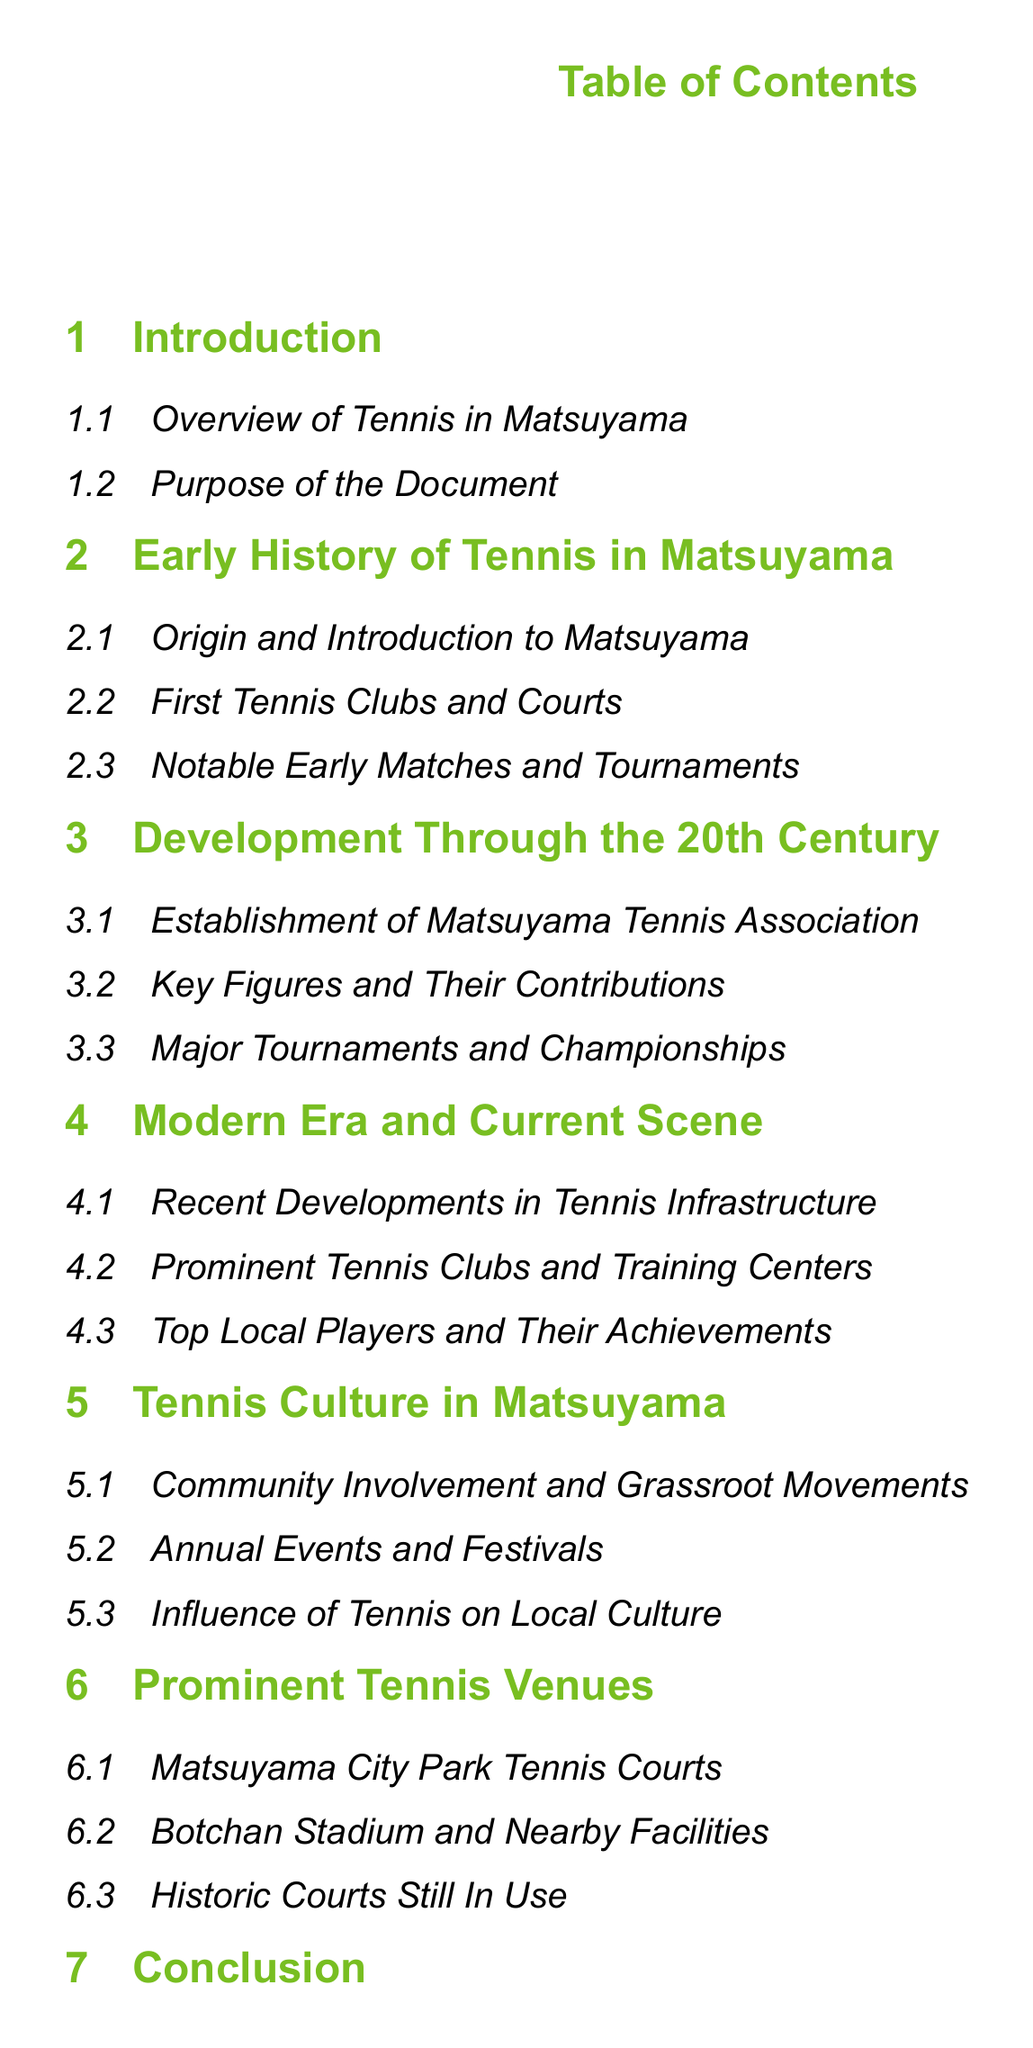What is the first section of the document? The first section listed in the Table of Contents is "Introduction."
Answer: Introduction How many subsections are in the section "Development Through the 20th Century"? There are three subsections under "Development Through the 20th Century."
Answer: 3 Who contributed to the establishment of the Matsuyama Tennis Association? The section "Key Figures and Their Contributions" addresses this topic.
Answer: Key Figures What are the main topics covered under "Tennis Culture in Matsuyama"? "Community Involvement and Grassroot Movements," "Annual Events and Festivals," and "Influence of Tennis on Local Culture."
Answer: Community Involvement and Grassroot Movements, Annual Events and Festivals, Influence of Tennis on Local Culture What historic venue is still in use according to the document? The section "Historic Courts Still In Use" mentions this topic.
Answer: Historic Courts What does the "Conclusion" section summarize? The "Conclusion" section contains a "Summary of Key Points."
Answer: Summary of Key Points Which subsection addresses recent developments in tennis infrastructure? The subsection focusing on recent improvements is "Recent Developments in Tennis Infrastructure."
Answer: Recent Developments in Tennis Infrastructure What is the document's purpose as stated in the first section? The purpose can be found in the subsection "Purpose of the Document."
Answer: Purpose of the Document When did the first tennis clubs emerge in Matsuyama? This information is found in the subsection "First Tennis Clubs and Courts."
Answer: First Tennis Clubs and Courts 